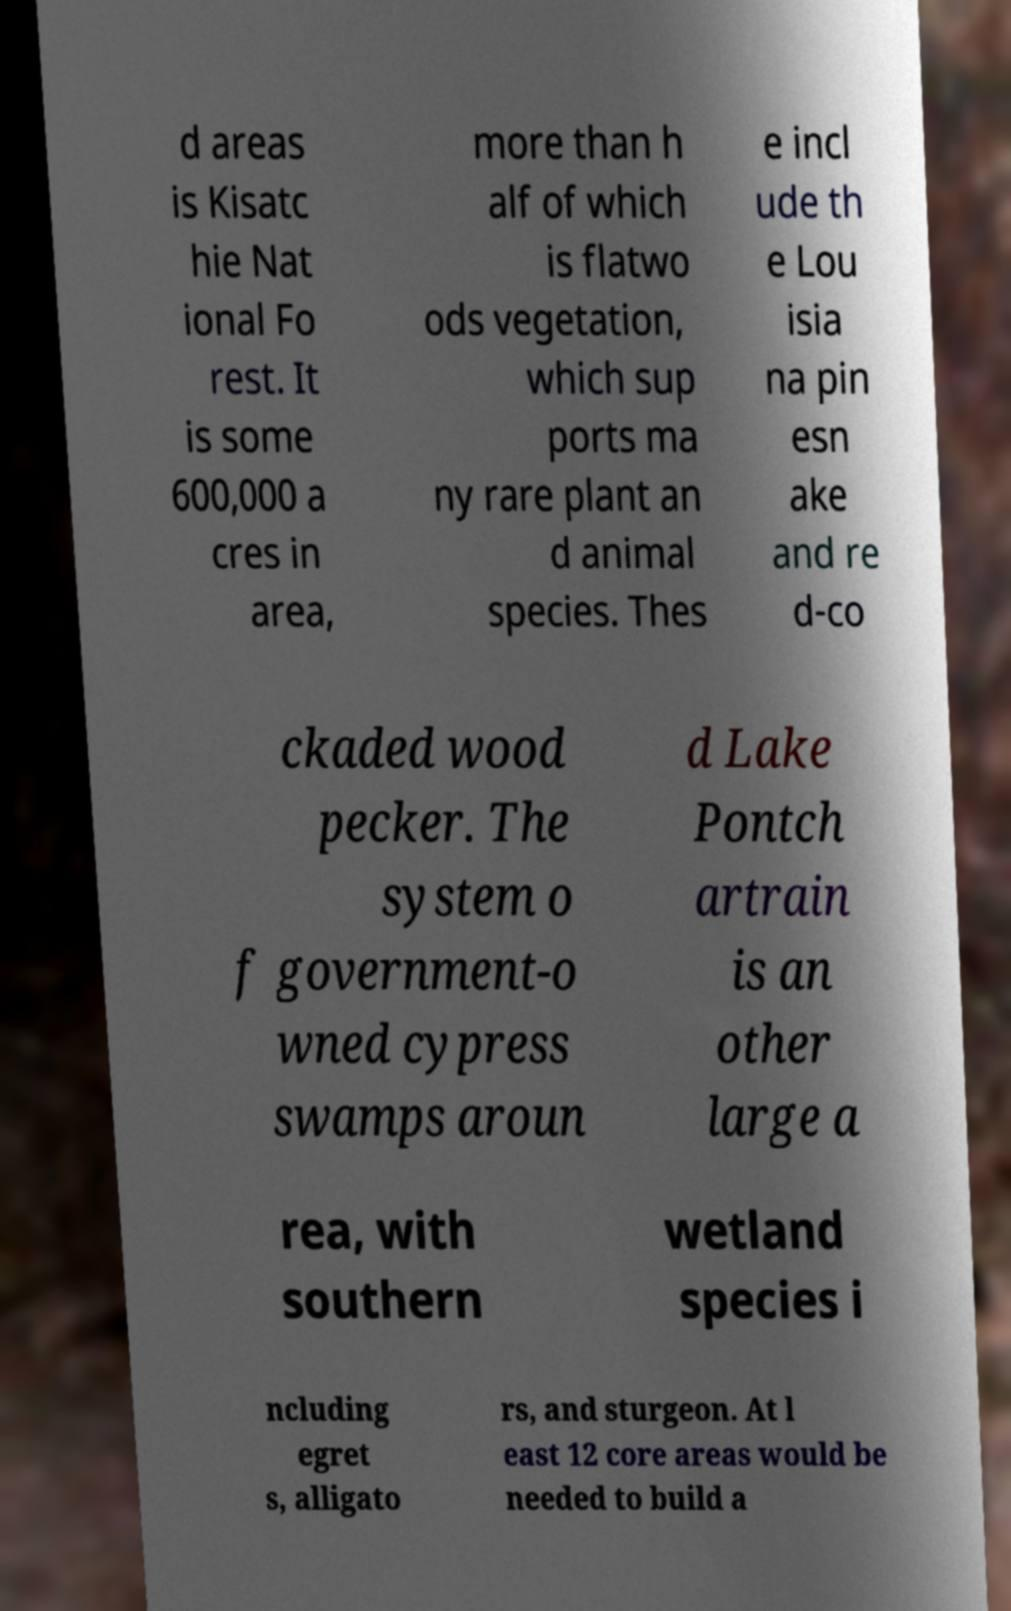Can you accurately transcribe the text from the provided image for me? d areas is Kisatc hie Nat ional Fo rest. It is some 600,000 a cres in area, more than h alf of which is flatwo ods vegetation, which sup ports ma ny rare plant an d animal species. Thes e incl ude th e Lou isia na pin esn ake and re d-co ckaded wood pecker. The system o f government-o wned cypress swamps aroun d Lake Pontch artrain is an other large a rea, with southern wetland species i ncluding egret s, alligato rs, and sturgeon. At l east 12 core areas would be needed to build a 